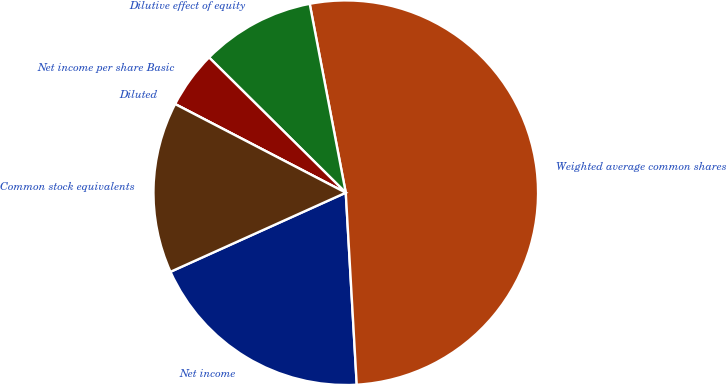<chart> <loc_0><loc_0><loc_500><loc_500><pie_chart><fcel>Net income<fcel>Weighted average common shares<fcel>Dilutive effect of equity<fcel>Net income per share Basic<fcel>Diluted<fcel>Common stock equivalents<nl><fcel>19.16%<fcel>52.09%<fcel>9.58%<fcel>4.79%<fcel>0.0%<fcel>14.37%<nl></chart> 